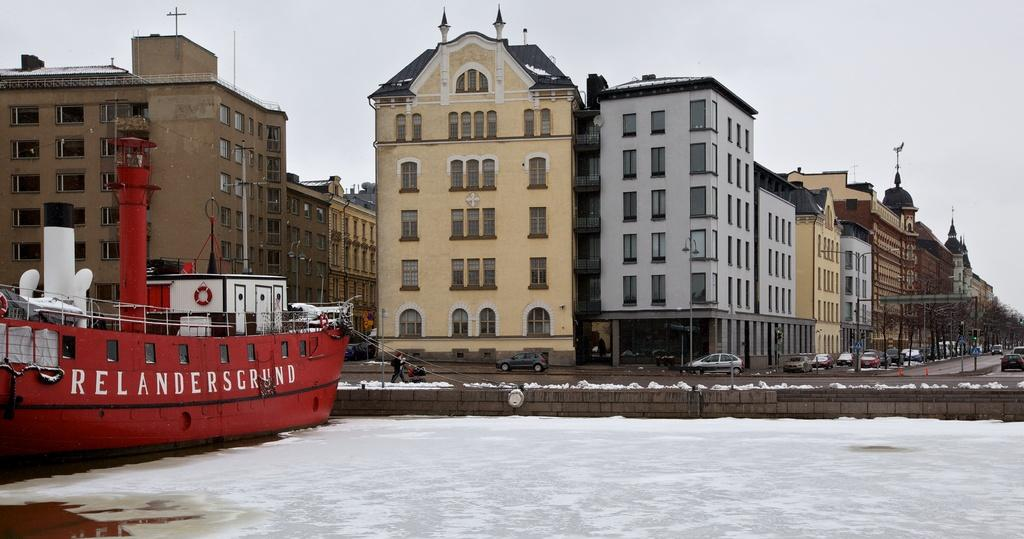What type of structures can be seen in the image? There are buildings in the image. What is located in the water in the image? There is a ship in the water. What type of vehicles are parked in the image? There are cars parked in the image. What type of vegetation is present in the image? There are trees in the image. What is the man in the image doing? There is a man walking on the sidewalk in the image. What is the weather like in the image? There is snow visible in the image, and the sky is cloudy. What book is the man reading while walking on the sidewalk in the image? There is no book present in the image, and the man is not reading while walking. What type of station is visible in the image? There is no station present in the image. 